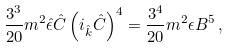Convert formula to latex. <formula><loc_0><loc_0><loc_500><loc_500>{ \frac { 3 ^ { 3 } } { 2 0 } } m ^ { 2 } \hat { \epsilon } \hat { C } \left ( i _ { \hat { k } } \hat { C } \right ) ^ { 4 } = { \frac { 3 ^ { 4 } } { 2 0 } } m ^ { 2 } \epsilon B ^ { 5 } \, ,</formula> 